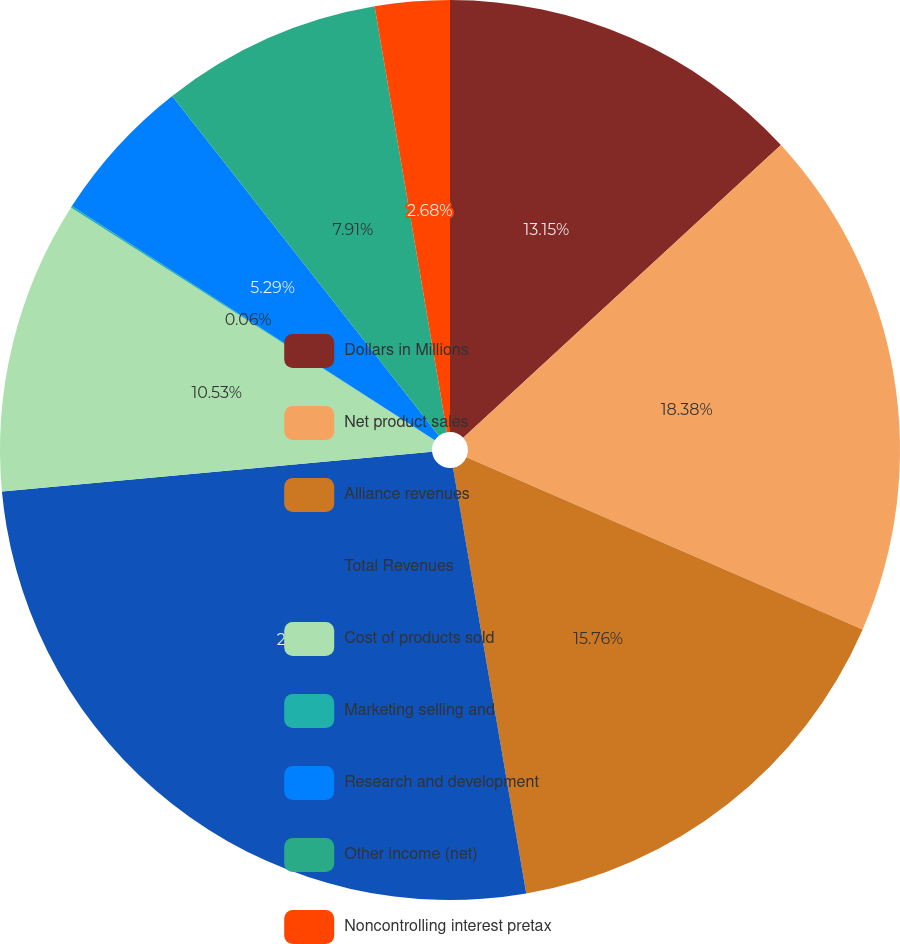Convert chart to OTSL. <chart><loc_0><loc_0><loc_500><loc_500><pie_chart><fcel>Dollars in Millions<fcel>Net product sales<fcel>Alliance revenues<fcel>Total Revenues<fcel>Cost of products sold<fcel>Marketing selling and<fcel>Research and development<fcel>Other income (net)<fcel>Noncontrolling interest pretax<nl><fcel>13.15%<fcel>18.38%<fcel>15.76%<fcel>26.24%<fcel>10.53%<fcel>0.06%<fcel>5.29%<fcel>7.91%<fcel>2.68%<nl></chart> 